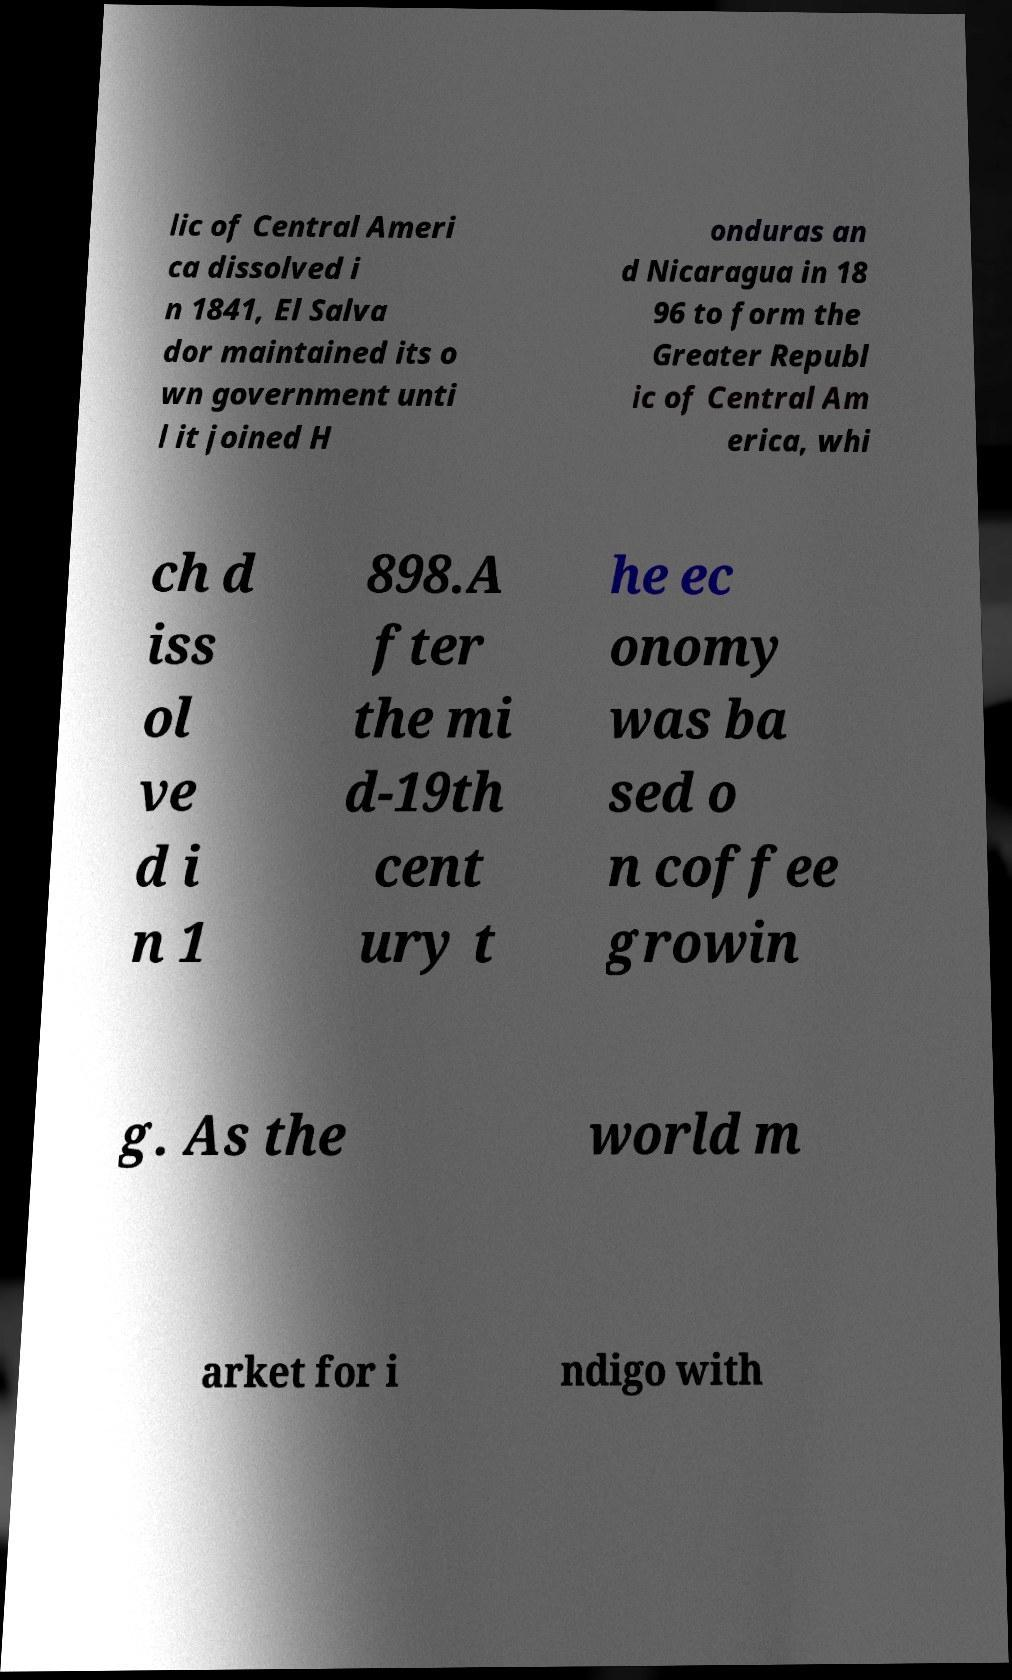What messages or text are displayed in this image? I need them in a readable, typed format. lic of Central Ameri ca dissolved i n 1841, El Salva dor maintained its o wn government unti l it joined H onduras an d Nicaragua in 18 96 to form the Greater Republ ic of Central Am erica, whi ch d iss ol ve d i n 1 898.A fter the mi d-19th cent ury t he ec onomy was ba sed o n coffee growin g. As the world m arket for i ndigo with 